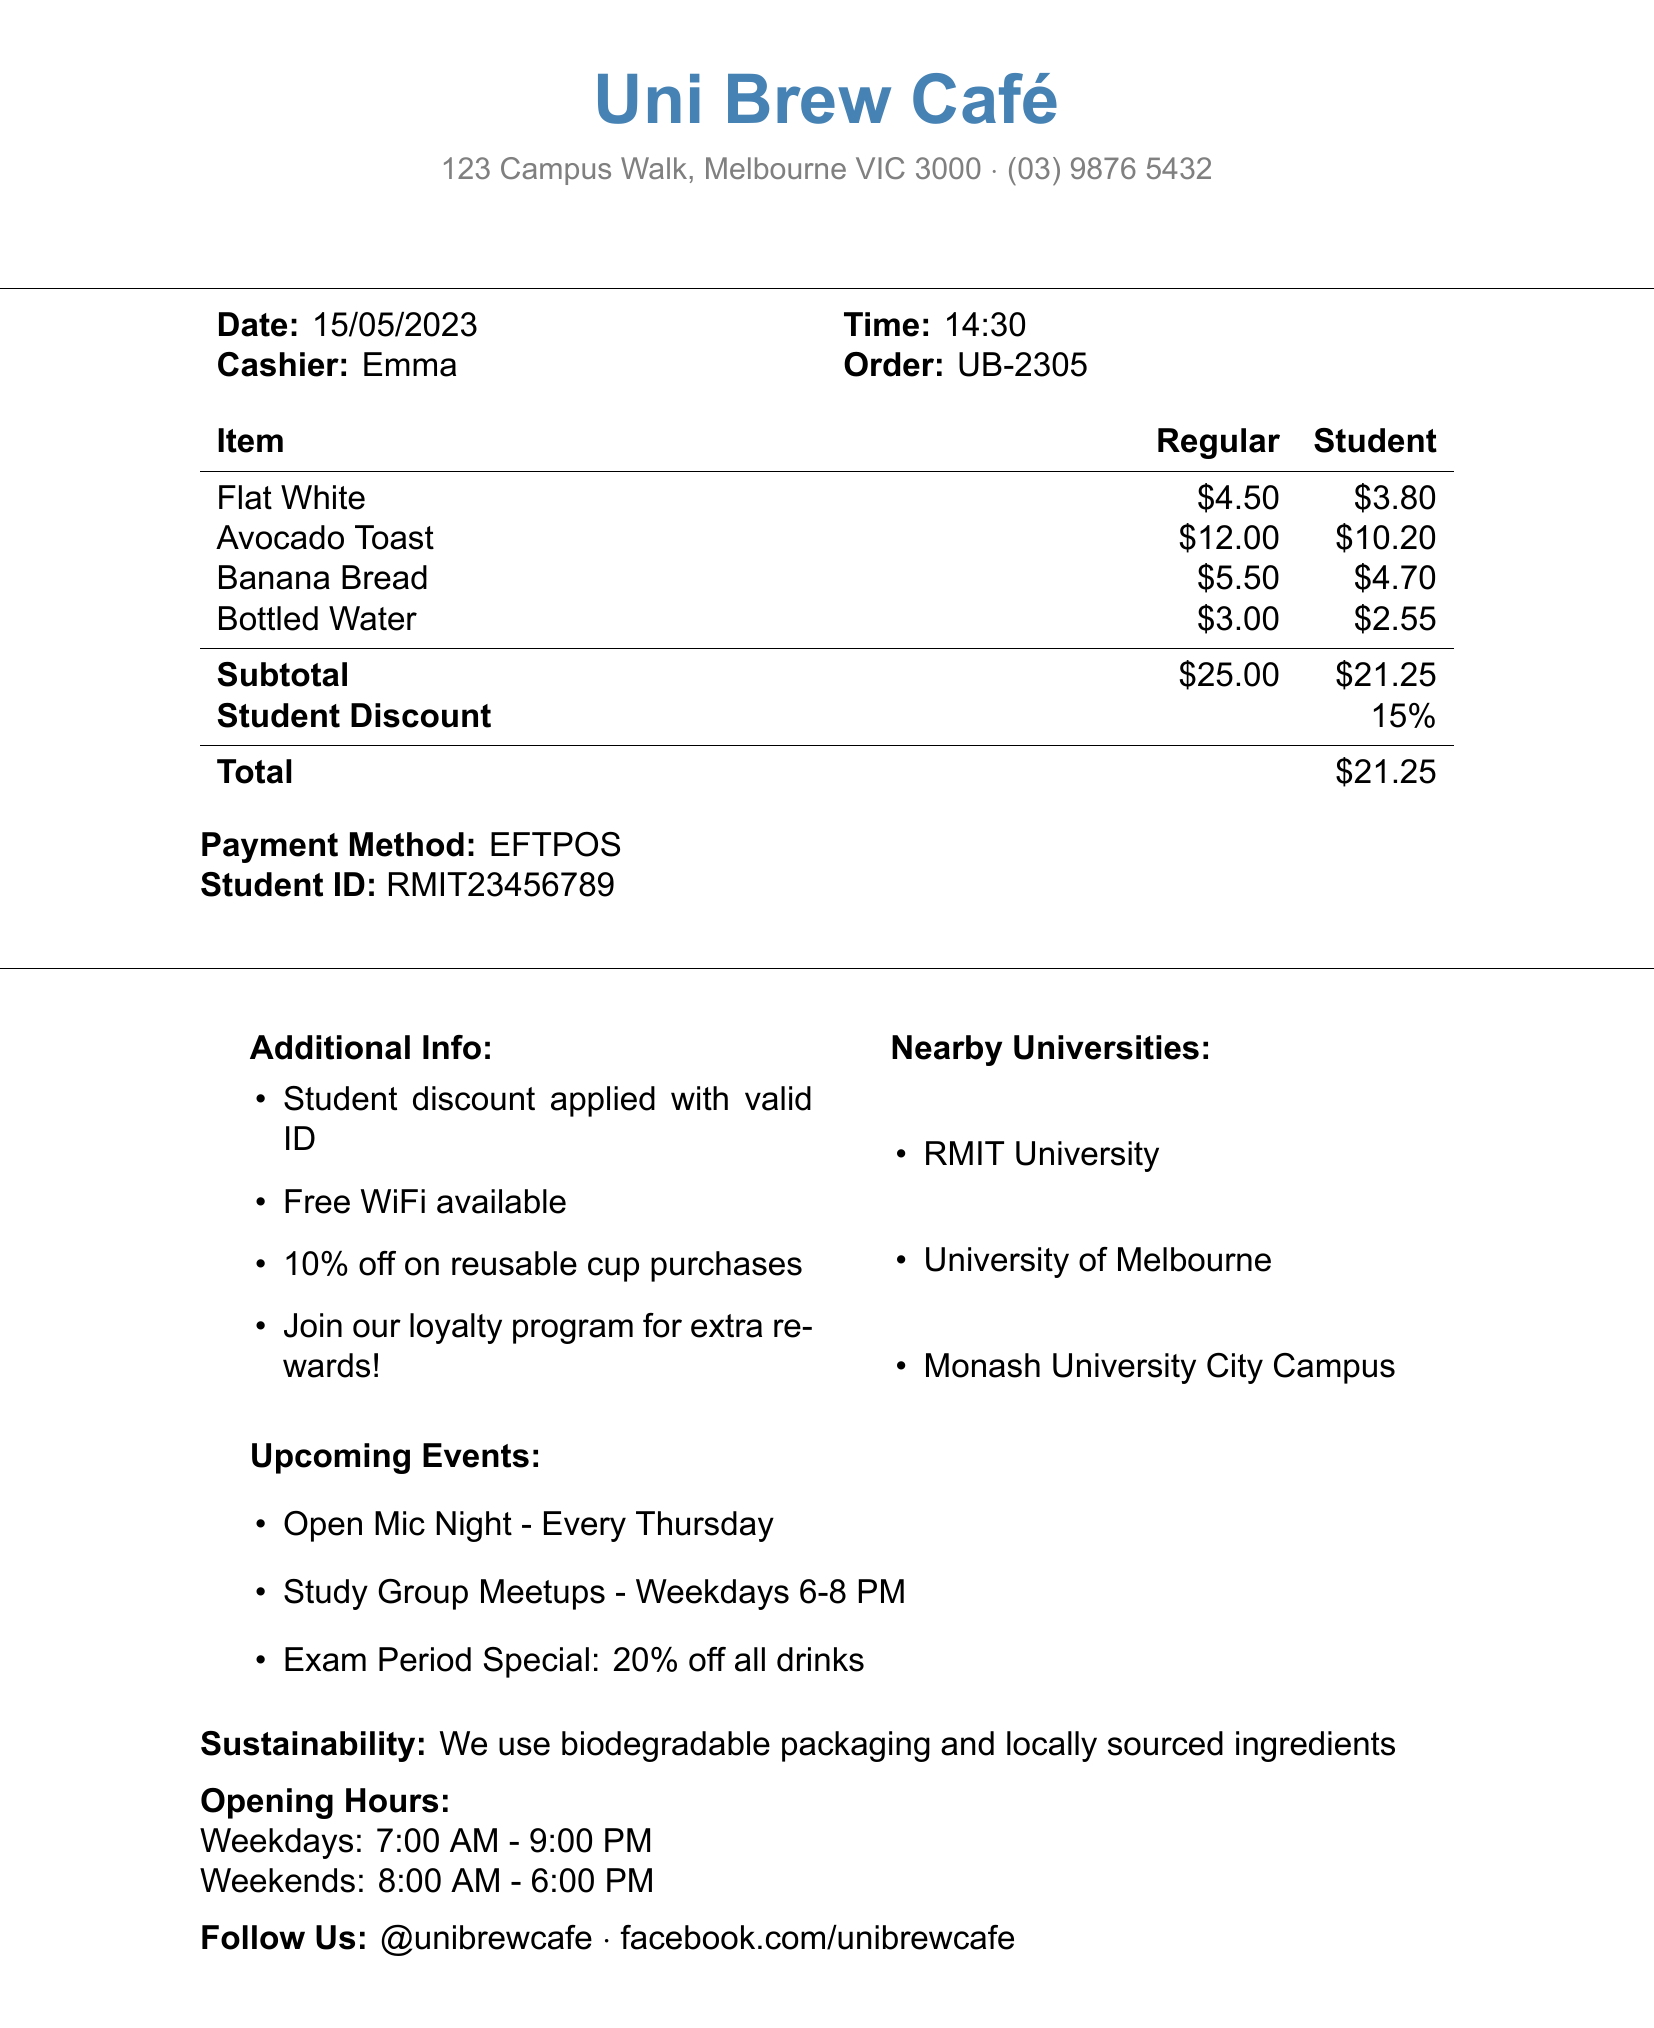what is the coffee shop's name? The coffee shop's name is listed at the top of the receipt.
Answer: Uni Brew Café what is the total amount after applying student discount? The total amount is calculated after applying the student discount to the subtotal.
Answer: $21.25 what was the date of the purchase? The date appears in the transaction details section of the receipt.
Answer: 15/05/2023 who was the cashier for the order? The cashier's name is indicated in the receipt details.
Answer: Emma what is the student discount percentage? The student discount percentage is mentioned in the subtotal section.
Answer: 15% how much does a Flat White cost for students? The student price for the Flat White is provided in the itemized list.
Answer: $3.80 what nearby university is mentioned on the receipt? The receipt lists nearby universities in a specific section.
Answer: RMIT University is there a loyalty program mentioned? The additional info includes details about a loyalty program.
Answer: Yes what special event occurs every Thursday? The upcoming events section refers to a specific event by day.
Answer: Open Mic Night 